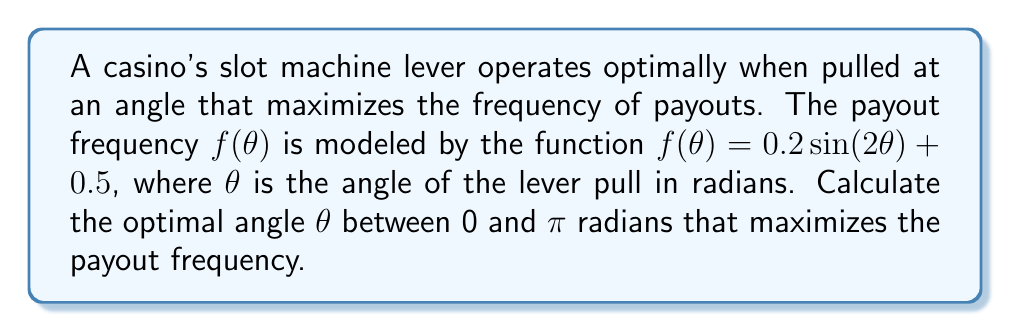Can you solve this math problem? To find the optimal angle, we need to maximize the function $f(\theta) = 0.2 \sin(2\theta) + 0.5$. We can do this by finding the derivative and setting it to zero.

1) First, let's find the derivative of $f(\theta)$:
   $$f'(\theta) = 0.2 \cdot 2 \cos(2\theta) = 0.4 \cos(2\theta)$$

2) Set the derivative to zero:
   $$0.4 \cos(2\theta) = 0$$

3) Solve for $\theta$:
   $$\cos(2\theta) = 0$$
   $$2\theta = \frac{\pi}{2} + \pi n, \text{ where } n \text{ is an integer}$$
   $$\theta = \frac{\pi}{4} + \frac{\pi n}{2}$$

4) Given the constraint that $\theta$ is between 0 and $\pi$, we have two solutions:
   $$\theta_1 = \frac{\pi}{4} \text{ and } \theta_2 = \frac{3\pi}{4}$$

5) To determine which one is the maximum, we can check the second derivative:
   $$f''(\theta) = -0.8 \sin(2\theta)$$

6) At $\theta = \frac{\pi}{4}$:
   $$f''(\frac{\pi}{4}) = -0.8 \sin(\frac{\pi}{2}) = -0.8 < 0$$
   This confirms that $\frac{\pi}{4}$ is a local maximum.

7) At $\theta = \frac{3\pi}{4}$:
   $$f''(\frac{3\pi}{4}) = -0.8 \sin(\frac{3\pi}{2}) = 0.8 > 0$$
   This confirms that $\frac{3\pi}{4}$ is a local minimum.

Therefore, the optimal angle to maximize payout frequency is $\frac{\pi}{4}$ radians.
Answer: $\frac{\pi}{4}$ radians 